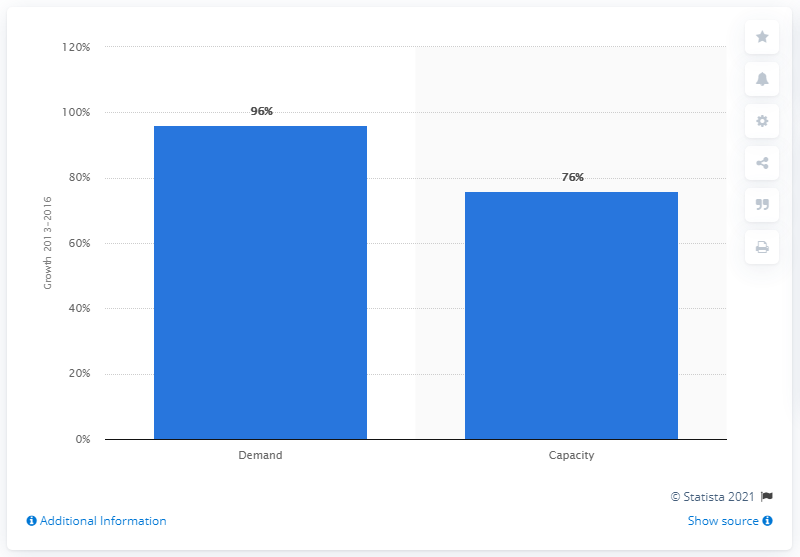Identify some key points in this picture. The expected increase in demand for sand between 2013 and 2016 is 96%. The predicted increase in sand capacities between 2013 and 2016 is expected to be approximately 76%. 